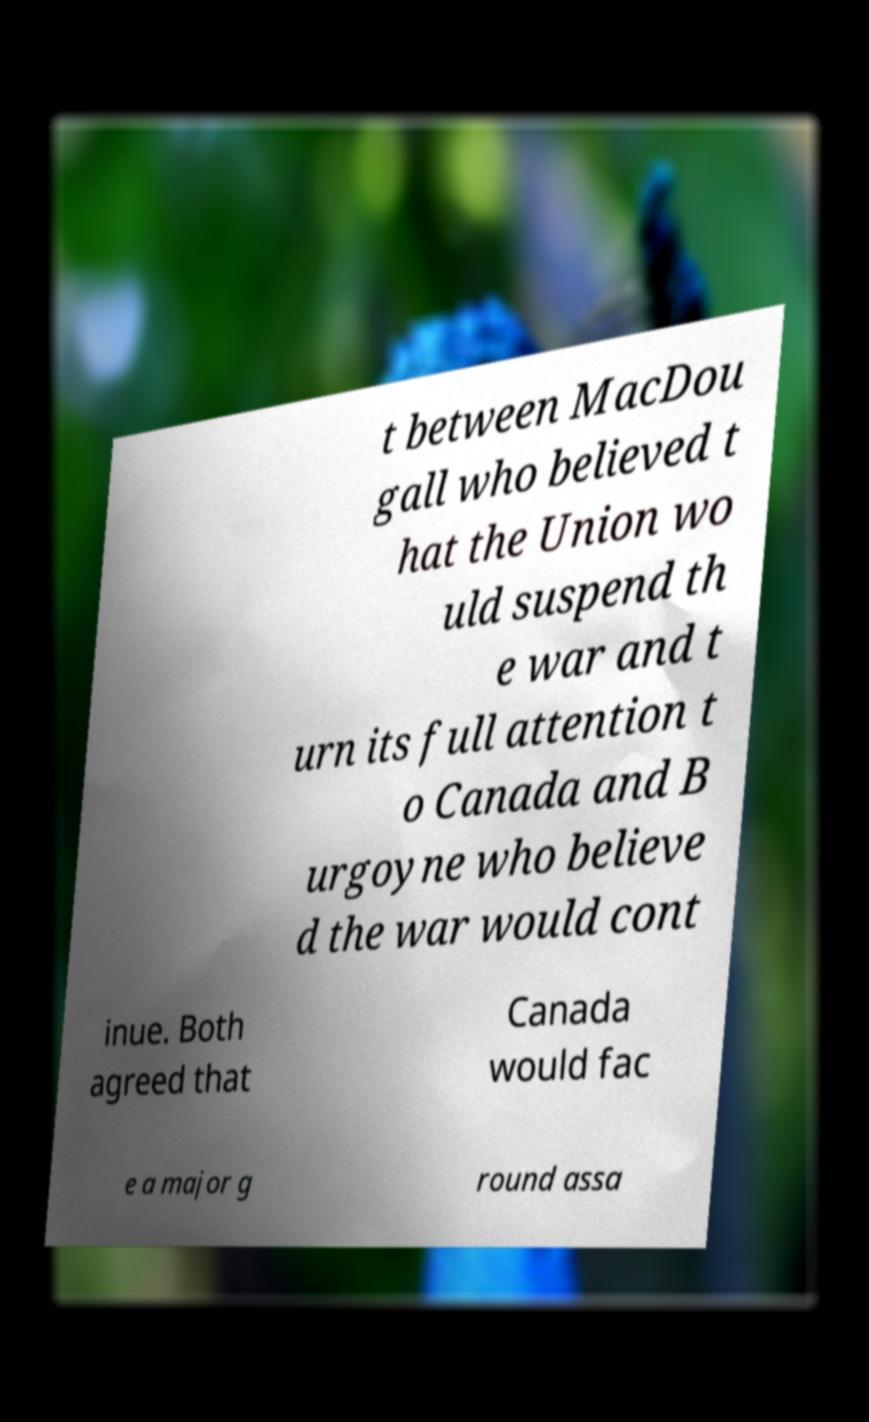There's text embedded in this image that I need extracted. Can you transcribe it verbatim? t between MacDou gall who believed t hat the Union wo uld suspend th e war and t urn its full attention t o Canada and B urgoyne who believe d the war would cont inue. Both agreed that Canada would fac e a major g round assa 